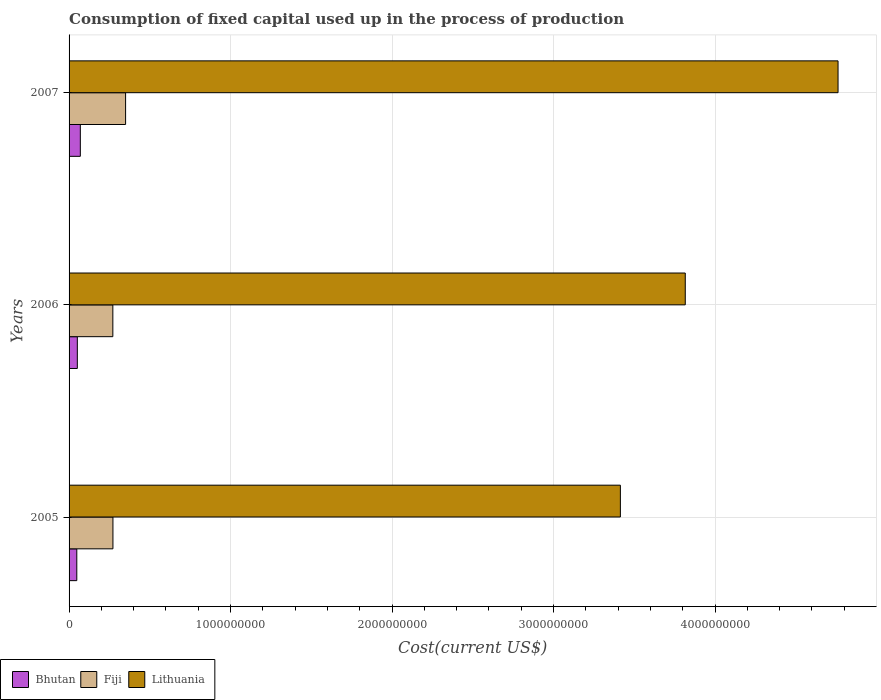How many bars are there on the 2nd tick from the top?
Your answer should be compact. 3. How many bars are there on the 2nd tick from the bottom?
Keep it short and to the point. 3. In how many cases, is the number of bars for a given year not equal to the number of legend labels?
Ensure brevity in your answer.  0. What is the amount consumed in the process of production in Lithuania in 2007?
Keep it short and to the point. 4.76e+09. Across all years, what is the maximum amount consumed in the process of production in Bhutan?
Keep it short and to the point. 6.97e+07. Across all years, what is the minimum amount consumed in the process of production in Lithuania?
Ensure brevity in your answer.  3.41e+09. In which year was the amount consumed in the process of production in Fiji maximum?
Your response must be concise. 2007. In which year was the amount consumed in the process of production in Lithuania minimum?
Give a very brief answer. 2005. What is the total amount consumed in the process of production in Lithuania in the graph?
Ensure brevity in your answer.  1.20e+1. What is the difference between the amount consumed in the process of production in Bhutan in 2006 and that in 2007?
Keep it short and to the point. -1.85e+07. What is the difference between the amount consumed in the process of production in Lithuania in 2005 and the amount consumed in the process of production in Bhutan in 2007?
Your answer should be very brief. 3.34e+09. What is the average amount consumed in the process of production in Lithuania per year?
Your answer should be compact. 4.00e+09. In the year 2005, what is the difference between the amount consumed in the process of production in Bhutan and amount consumed in the process of production in Lithuania?
Make the answer very short. -3.37e+09. What is the ratio of the amount consumed in the process of production in Bhutan in 2006 to that in 2007?
Provide a short and direct response. 0.73. Is the amount consumed in the process of production in Lithuania in 2005 less than that in 2006?
Provide a short and direct response. Yes. What is the difference between the highest and the second highest amount consumed in the process of production in Fiji?
Make the answer very short. 7.84e+07. What is the difference between the highest and the lowest amount consumed in the process of production in Lithuania?
Make the answer very short. 1.35e+09. Is the sum of the amount consumed in the process of production in Fiji in 2005 and 2006 greater than the maximum amount consumed in the process of production in Bhutan across all years?
Your answer should be very brief. Yes. What does the 2nd bar from the top in 2005 represents?
Provide a succinct answer. Fiji. What does the 3rd bar from the bottom in 2007 represents?
Ensure brevity in your answer.  Lithuania. Are all the bars in the graph horizontal?
Provide a short and direct response. Yes. Does the graph contain grids?
Keep it short and to the point. Yes. Where does the legend appear in the graph?
Offer a very short reply. Bottom left. What is the title of the graph?
Your answer should be compact. Consumption of fixed capital used up in the process of production. What is the label or title of the X-axis?
Keep it short and to the point. Cost(current US$). What is the Cost(current US$) of Bhutan in 2005?
Your answer should be very brief. 4.78e+07. What is the Cost(current US$) of Fiji in 2005?
Your answer should be compact. 2.72e+08. What is the Cost(current US$) in Lithuania in 2005?
Keep it short and to the point. 3.41e+09. What is the Cost(current US$) in Bhutan in 2006?
Give a very brief answer. 5.12e+07. What is the Cost(current US$) of Fiji in 2006?
Keep it short and to the point. 2.71e+08. What is the Cost(current US$) in Lithuania in 2006?
Your answer should be compact. 3.82e+09. What is the Cost(current US$) of Bhutan in 2007?
Ensure brevity in your answer.  6.97e+07. What is the Cost(current US$) of Fiji in 2007?
Provide a succinct answer. 3.50e+08. What is the Cost(current US$) in Lithuania in 2007?
Give a very brief answer. 4.76e+09. Across all years, what is the maximum Cost(current US$) in Bhutan?
Your answer should be very brief. 6.97e+07. Across all years, what is the maximum Cost(current US$) of Fiji?
Ensure brevity in your answer.  3.50e+08. Across all years, what is the maximum Cost(current US$) in Lithuania?
Offer a terse response. 4.76e+09. Across all years, what is the minimum Cost(current US$) of Bhutan?
Give a very brief answer. 4.78e+07. Across all years, what is the minimum Cost(current US$) of Fiji?
Your answer should be compact. 2.71e+08. Across all years, what is the minimum Cost(current US$) of Lithuania?
Make the answer very short. 3.41e+09. What is the total Cost(current US$) in Bhutan in the graph?
Make the answer very short. 1.69e+08. What is the total Cost(current US$) in Fiji in the graph?
Offer a terse response. 8.93e+08. What is the total Cost(current US$) in Lithuania in the graph?
Your response must be concise. 1.20e+1. What is the difference between the Cost(current US$) of Bhutan in 2005 and that in 2006?
Your response must be concise. -3.34e+06. What is the difference between the Cost(current US$) of Fiji in 2005 and that in 2006?
Provide a succinct answer. 5.63e+05. What is the difference between the Cost(current US$) in Lithuania in 2005 and that in 2006?
Provide a short and direct response. -4.02e+08. What is the difference between the Cost(current US$) in Bhutan in 2005 and that in 2007?
Your response must be concise. -2.19e+07. What is the difference between the Cost(current US$) in Fiji in 2005 and that in 2007?
Your answer should be compact. -7.84e+07. What is the difference between the Cost(current US$) of Lithuania in 2005 and that in 2007?
Offer a very short reply. -1.35e+09. What is the difference between the Cost(current US$) of Bhutan in 2006 and that in 2007?
Make the answer very short. -1.85e+07. What is the difference between the Cost(current US$) of Fiji in 2006 and that in 2007?
Offer a terse response. -7.90e+07. What is the difference between the Cost(current US$) in Lithuania in 2006 and that in 2007?
Make the answer very short. -9.46e+08. What is the difference between the Cost(current US$) in Bhutan in 2005 and the Cost(current US$) in Fiji in 2006?
Your answer should be compact. -2.23e+08. What is the difference between the Cost(current US$) of Bhutan in 2005 and the Cost(current US$) of Lithuania in 2006?
Provide a short and direct response. -3.77e+09. What is the difference between the Cost(current US$) of Fiji in 2005 and the Cost(current US$) of Lithuania in 2006?
Ensure brevity in your answer.  -3.54e+09. What is the difference between the Cost(current US$) of Bhutan in 2005 and the Cost(current US$) of Fiji in 2007?
Keep it short and to the point. -3.02e+08. What is the difference between the Cost(current US$) of Bhutan in 2005 and the Cost(current US$) of Lithuania in 2007?
Provide a short and direct response. -4.71e+09. What is the difference between the Cost(current US$) of Fiji in 2005 and the Cost(current US$) of Lithuania in 2007?
Provide a short and direct response. -4.49e+09. What is the difference between the Cost(current US$) in Bhutan in 2006 and the Cost(current US$) in Fiji in 2007?
Keep it short and to the point. -2.99e+08. What is the difference between the Cost(current US$) of Bhutan in 2006 and the Cost(current US$) of Lithuania in 2007?
Ensure brevity in your answer.  -4.71e+09. What is the difference between the Cost(current US$) of Fiji in 2006 and the Cost(current US$) of Lithuania in 2007?
Offer a terse response. -4.49e+09. What is the average Cost(current US$) in Bhutan per year?
Offer a very short reply. 5.62e+07. What is the average Cost(current US$) of Fiji per year?
Give a very brief answer. 2.98e+08. What is the average Cost(current US$) in Lithuania per year?
Offer a very short reply. 4.00e+09. In the year 2005, what is the difference between the Cost(current US$) in Bhutan and Cost(current US$) in Fiji?
Keep it short and to the point. -2.24e+08. In the year 2005, what is the difference between the Cost(current US$) of Bhutan and Cost(current US$) of Lithuania?
Offer a terse response. -3.37e+09. In the year 2005, what is the difference between the Cost(current US$) in Fiji and Cost(current US$) in Lithuania?
Offer a very short reply. -3.14e+09. In the year 2006, what is the difference between the Cost(current US$) in Bhutan and Cost(current US$) in Fiji?
Keep it short and to the point. -2.20e+08. In the year 2006, what is the difference between the Cost(current US$) in Bhutan and Cost(current US$) in Lithuania?
Make the answer very short. -3.76e+09. In the year 2006, what is the difference between the Cost(current US$) of Fiji and Cost(current US$) of Lithuania?
Provide a short and direct response. -3.54e+09. In the year 2007, what is the difference between the Cost(current US$) in Bhutan and Cost(current US$) in Fiji?
Provide a short and direct response. -2.80e+08. In the year 2007, what is the difference between the Cost(current US$) in Bhutan and Cost(current US$) in Lithuania?
Your answer should be compact. -4.69e+09. In the year 2007, what is the difference between the Cost(current US$) in Fiji and Cost(current US$) in Lithuania?
Keep it short and to the point. -4.41e+09. What is the ratio of the Cost(current US$) of Bhutan in 2005 to that in 2006?
Provide a short and direct response. 0.93. What is the ratio of the Cost(current US$) in Lithuania in 2005 to that in 2006?
Provide a short and direct response. 0.89. What is the ratio of the Cost(current US$) of Bhutan in 2005 to that in 2007?
Give a very brief answer. 0.69. What is the ratio of the Cost(current US$) in Fiji in 2005 to that in 2007?
Provide a succinct answer. 0.78. What is the ratio of the Cost(current US$) in Lithuania in 2005 to that in 2007?
Provide a short and direct response. 0.72. What is the ratio of the Cost(current US$) of Bhutan in 2006 to that in 2007?
Ensure brevity in your answer.  0.73. What is the ratio of the Cost(current US$) in Fiji in 2006 to that in 2007?
Your response must be concise. 0.77. What is the ratio of the Cost(current US$) in Lithuania in 2006 to that in 2007?
Offer a very short reply. 0.8. What is the difference between the highest and the second highest Cost(current US$) of Bhutan?
Provide a succinct answer. 1.85e+07. What is the difference between the highest and the second highest Cost(current US$) in Fiji?
Provide a succinct answer. 7.84e+07. What is the difference between the highest and the second highest Cost(current US$) of Lithuania?
Make the answer very short. 9.46e+08. What is the difference between the highest and the lowest Cost(current US$) of Bhutan?
Provide a succinct answer. 2.19e+07. What is the difference between the highest and the lowest Cost(current US$) of Fiji?
Your answer should be very brief. 7.90e+07. What is the difference between the highest and the lowest Cost(current US$) of Lithuania?
Offer a terse response. 1.35e+09. 